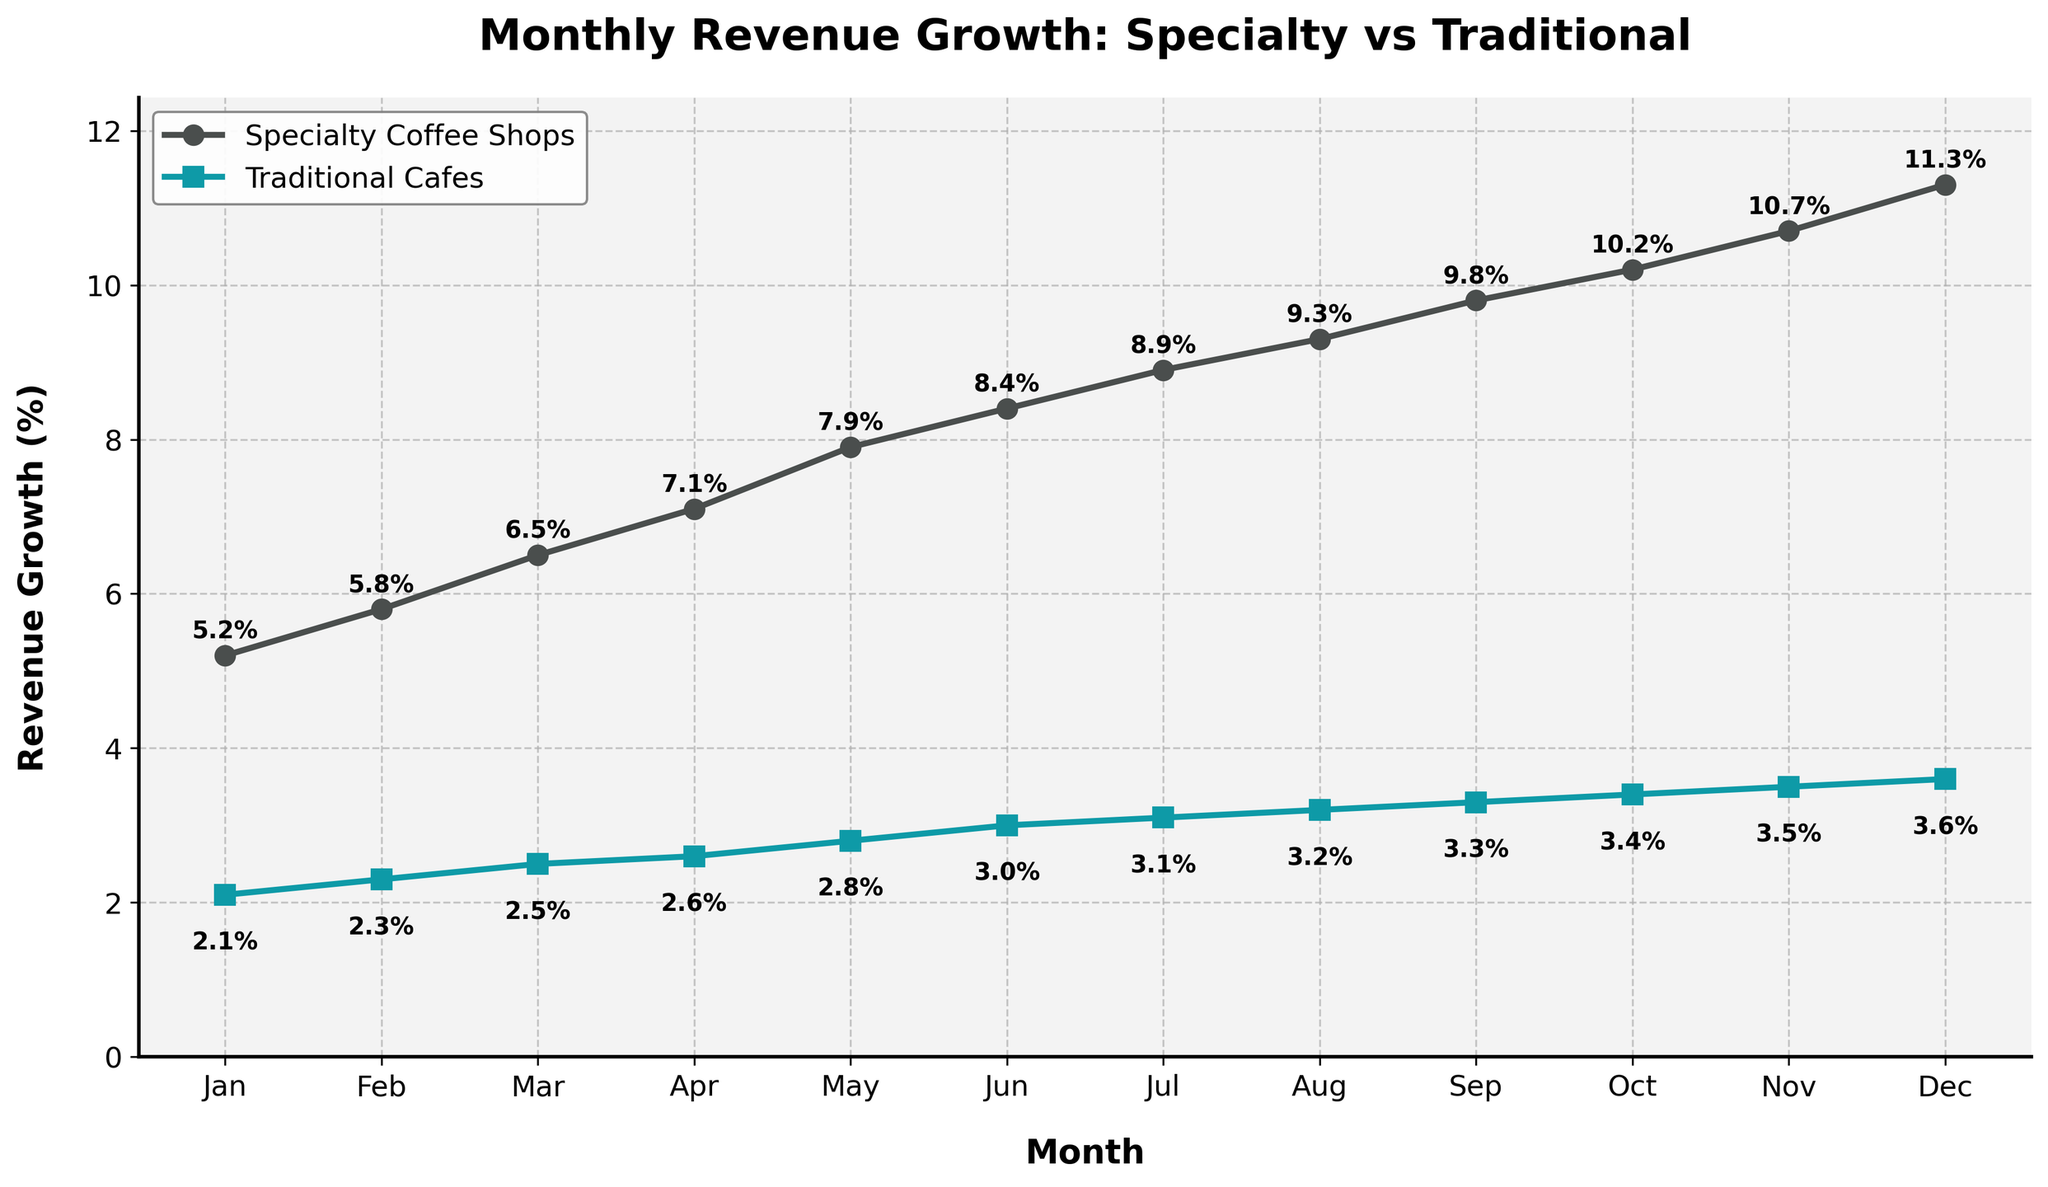What is the difference in revenue growth between Specialty Coffee Shops and Traditional Cafes in July? To find the difference, subtract the revenue growth percentage of Traditional Cafes from that of Specialty Coffee Shops for July. Specialty Coffee Shops have 8.9% and Traditional Cafes have 3.1%. Therefore, 8.9% - 3.1% = 5.8%.
Answer: 5.8% What month shows the highest revenue growth for Specialty Coffee Shops? Look at the plot and identify the month with the highest data point on the Specialty Coffee Shops line. The highest point is in December with 11.3%.
Answer: December Which type of shop had more consistent revenue growth over the months? Consistency can be measured by observing the amount of variation in the lines. The line for Traditional Cafes is relatively flat with slight increases each month, indicating more consistent revenue growth compared to the steeper increases for Specialty Coffee Shops.
Answer: Traditional Cafes What is the percentage increase in revenue growth for Traditional Cafes from January to December? Subtract the revenue growth of January from December and divide by January's growth, then multiply by 100 to convert to percentage. (3.6% - 2.1%) / 2.1% * 100 = 71.43%.
Answer: 71.43% In which month did Traditional Cafes surpass a 3% revenue growth? Look at the Traditional Cafes line on the plot and find the first month when the value exceeds 3%. This occurs in June.
Answer: June During which month do Specialty Coffee Shops experience the smallest increase in revenue growth compared to the previous month? Look for the smallest gap between consecutive data points on the Specialty Coffee Shops line. The smallest increase is from July (8.9%) to August (9.3%), which is 0.4%.
Answer: August By how much did the revenue growth for Specialty Coffee Shops exceed that of Traditional Cafes in December? Subtract the revenue growth percentage of Traditional Cafes from the Specialty Coffee Shops for December. Specialty Coffee Shops have 11.3% and Traditional Cafes have 3.6%. Therefore, 11.3% - 3.6% = 7.7%.
Answer: 7.7% What is the average revenue growth for Specialty Coffee Shops over the entire year? Sum all the monthly revenue growth percentages for Specialty Coffee Shops and divide by 12. (5.2 + 5.8 + 6.5 + 7.1 + 7.9 + 8.4 + 8.9 + 9.3 + 9.8 + 10.2 + 10.7 + 11.3) / 12 = 8.345%.
Answer: 8.345% How much did the revenue growth gap between Specialty Coffee Shops and Traditional Cafes widen from January to December? Calculate the differences for January and December, then subtract the January difference from the December difference. For January (5.2% - 2.1% = 3.1%), for December (11.3% - 3.6% = 7.7%). Then, 7.7% - 3.1% = 4.6%.
Answer: 4.6% 